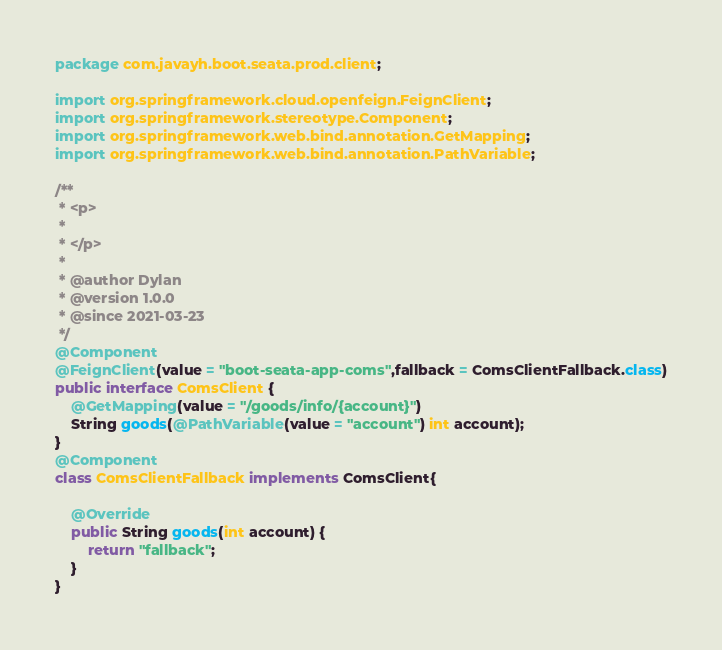<code> <loc_0><loc_0><loc_500><loc_500><_Java_>package com.javayh.boot.seata.prod.client;

import org.springframework.cloud.openfeign.FeignClient;
import org.springframework.stereotype.Component;
import org.springframework.web.bind.annotation.GetMapping;
import org.springframework.web.bind.annotation.PathVariable;

/**
 * <p>
 *
 * </p>
 *
 * @author Dylan
 * @version 1.0.0
 * @since 2021-03-23
 */
@Component
@FeignClient(value = "boot-seata-app-coms",fallback = ComsClientFallback.class)
public interface ComsClient {
    @GetMapping(value = "/goods/info/{account}")
    String goods(@PathVariable(value = "account") int account);
}
@Component
class ComsClientFallback implements ComsClient{

    @Override
    public String goods(int account) {
        return "fallback";
    }
}
</code> 